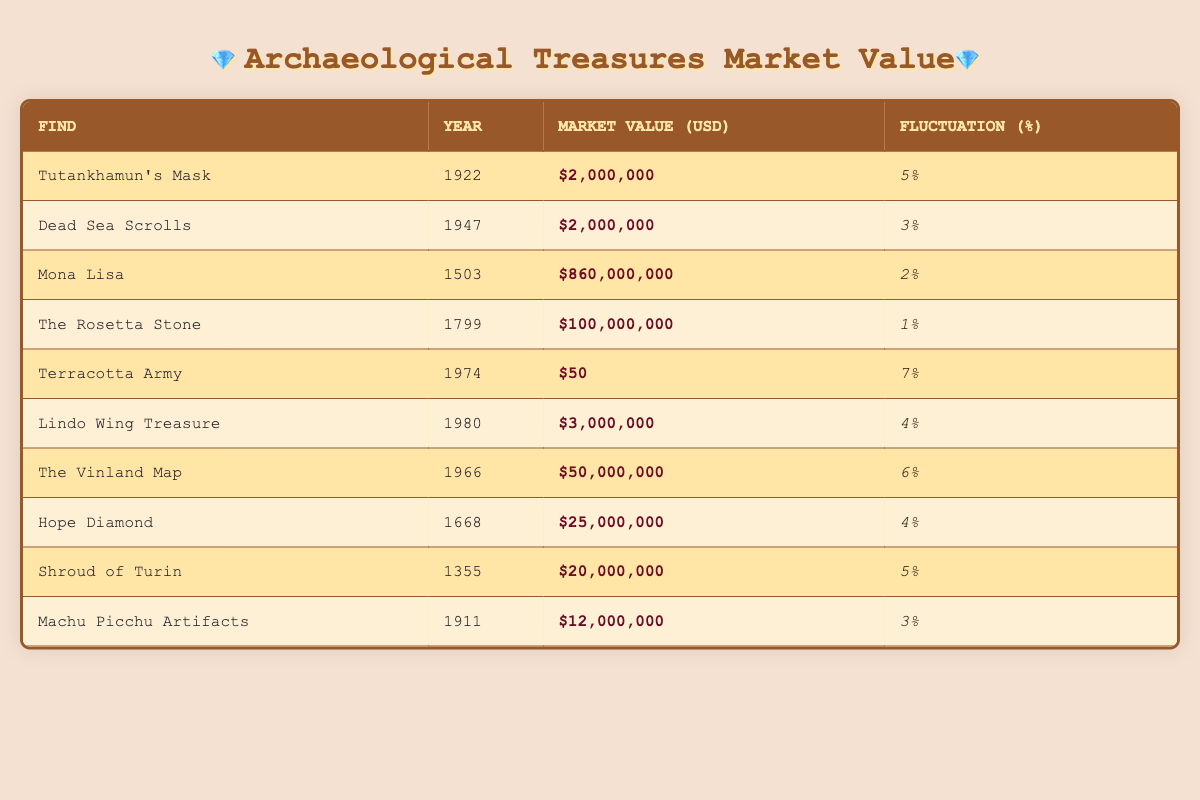What is the market value of the Hope Diamond? The table lists the Hope Diamond with a market value of $25,000,000.
Answer: $25,000,000 In which year was the Terracotta Army discovered? The table shows that the Terracotta Army was discovered in 1974.
Answer: 1974 Which archaeological find has the highest market value? By examining the market values, we see that the Mona Lisa has the highest market value at $860,000,000.
Answer: Mona Lisa What is the fluctuation percentage of the Dead Sea Scrolls? The table indicates that the fluctuation percentage for the Dead Sea Scrolls is 3%.
Answer: 3% How many finds have a market value of over $50,000,000? The data shows five finds: Mona Lisa, The Rosetta Stone, The Vinland Map, followed by Hope Diamond and the Terracotta Army which is $50. Since only the first three have a value over $50,000,000, the count is 3.
Answer: 3 What is the average market value of the finds discovered after 1970? The finds after 1970 are Terracotta Army ($50), Lindo Wing Treasure ($3,000,000), and The Vinland Map ($50,000,000). First, sum them ($50 + $3,000,000 + $50,000,000 = $53,003,050). Then, divide by the number of finds (3): $53,003,050 ÷ 3 = $17,667,683.33, rounding gives approximately $17,667,683.
Answer: $17,667,683 Is the fluctuation percentage of Tutankhamun's Mask higher than that of the Shroud of Turin? Comparing the fluctuation percentages, Tutankhamun's Mask has 5% and the Shroud of Turin also has 5%. Since they are equal, the answer is no.
Answer: No What is the difference in market value between the Mona Lisa and the Dead Sea Scrolls? The Mona Lisa is valued at $860,000,000 while the Dead Sea Scrolls are at $2,000,000. The difference is calculated as $860,000,000 - $2,000,000 = $858,000,000.
Answer: $858,000,000 Which find has a lower fluctuation percentage, the Hope Diamond or the Lindo Wing Treasure? The Hope Diamond has a fluctuation of 4% while the Lindo Wing Treasure also has a fluctuation of 4%. Hence, they are equal and neither has a lower percentage.
Answer: No How many finds have a fluctuation percentage of 5% or higher? The finds with 5% or higher are: Tutankhamun's Mask (5%), Terracotta Army (7%), Vinland Map (6%), Shroud of Turin (5%). This totals four finds.
Answer: 4 